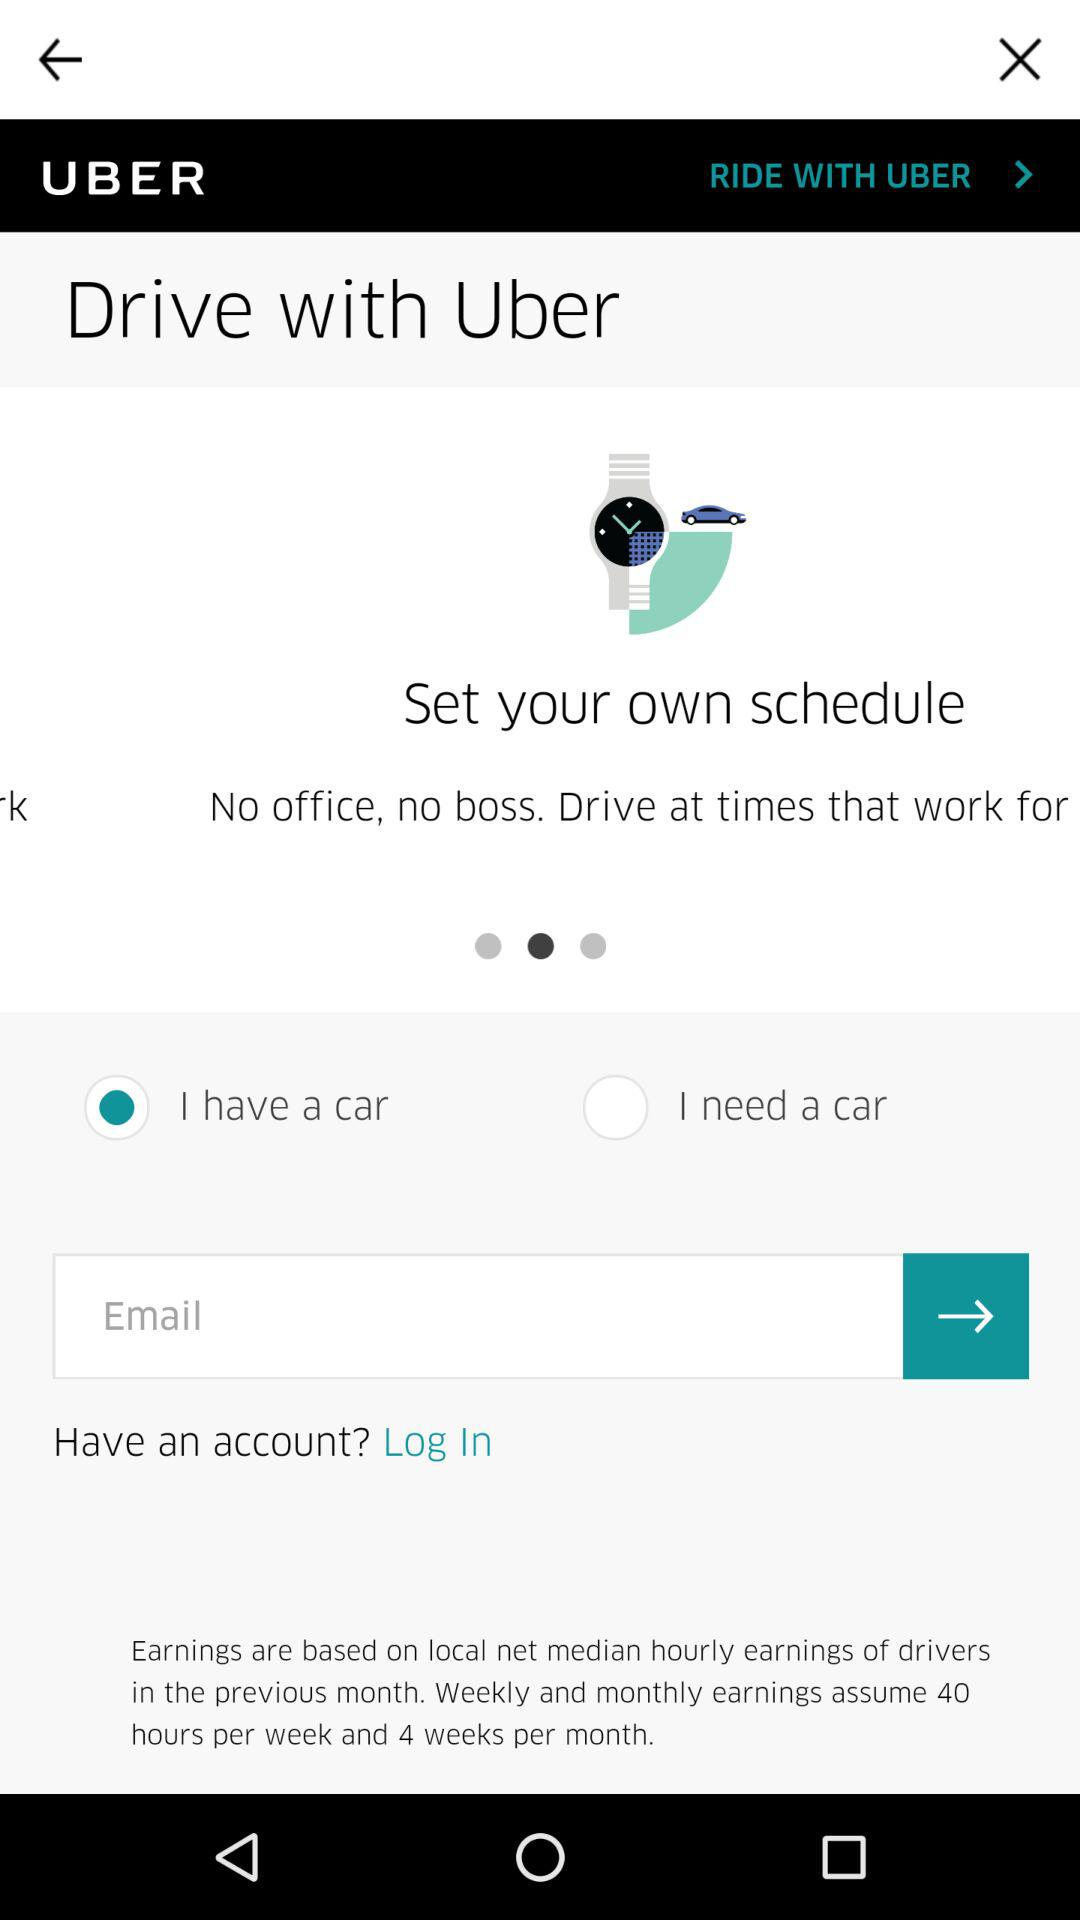How many hours per week, weekly and monthly earnings are assumed? Weekly and monthly earnings assume 40 hours per week. 